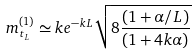<formula> <loc_0><loc_0><loc_500><loc_500>m ^ { ( 1 ) } _ { t _ { L } } \simeq k e ^ { - k L } \sqrt { 8 \frac { ( 1 + \alpha / L ) } { ( 1 + 4 k \alpha ) } }</formula> 